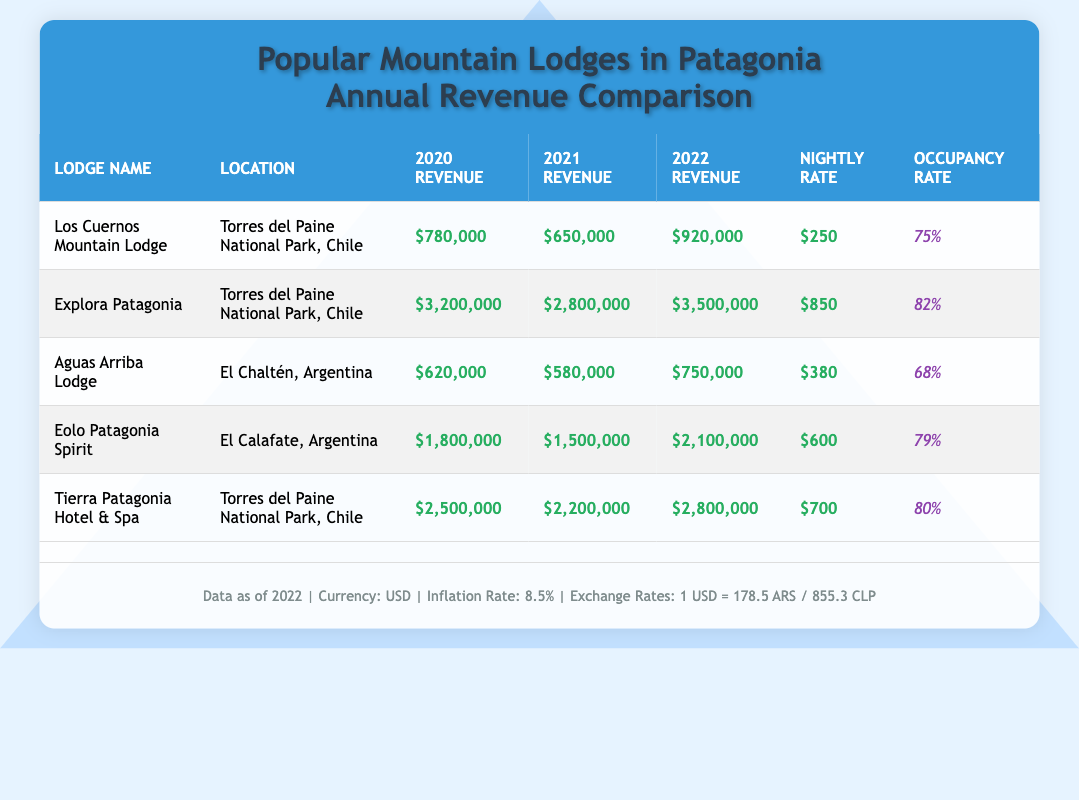What was the highest annual revenue for Explora Patagonia? According to the table, the data for Explora Patagonia shows annual revenues of $3,200,000 in 2020, $2,800,000 in 2021, and $3,500,000 in 2022. Comparing these values, the highest is $3,500,000 in 2022.
Answer: $3,500,000 What is the average occupancy rate of the lodges listed? The occupancy rates for the lodges are 75%, 82%, 68%, 79%, and 80%. To find the average, add them up (75 + 82 + 68 + 79 + 80) = 384, then divide by the number of lodges (5), which gives 384/5 = 76.8%.
Answer: 76.8% Did Aguas Arriba Lodge have an annual revenue above $700,000 in any of the years listed? The annual revenues for Aguas Arriba Lodge are $620,000 in 2020, $580,000 in 2021, and $750,000 in 2022. Since only the revenue for 2022 exceeds $700,000, the answer is yes.
Answer: Yes Which lodge had the lowest annual revenue in 2021? From the table, the annual revenue for each lodge in 2021 is $650,000 (Los Cuernos), $2,800,000 (Explora), $580,000 (Aguas Arriba), $1,500,000 (Eolo), and $2,200,000 (Tierra). The lowest is $580,000 from Aguas Arriba Lodge.
Answer: Aguas Arriba Lodge What are the total revenues of the lodges in 2022? To find the total revenue for 2022, add all the listed annual revenues: $920,000 (Los Cuernos) + $3,500,000 (Explora) + $750,000 (Aguas Arriba) + $2,100,000 (Eolo) + $2,800,000 (Tierra) = $10,070,000.
Answer: $10,070,000 